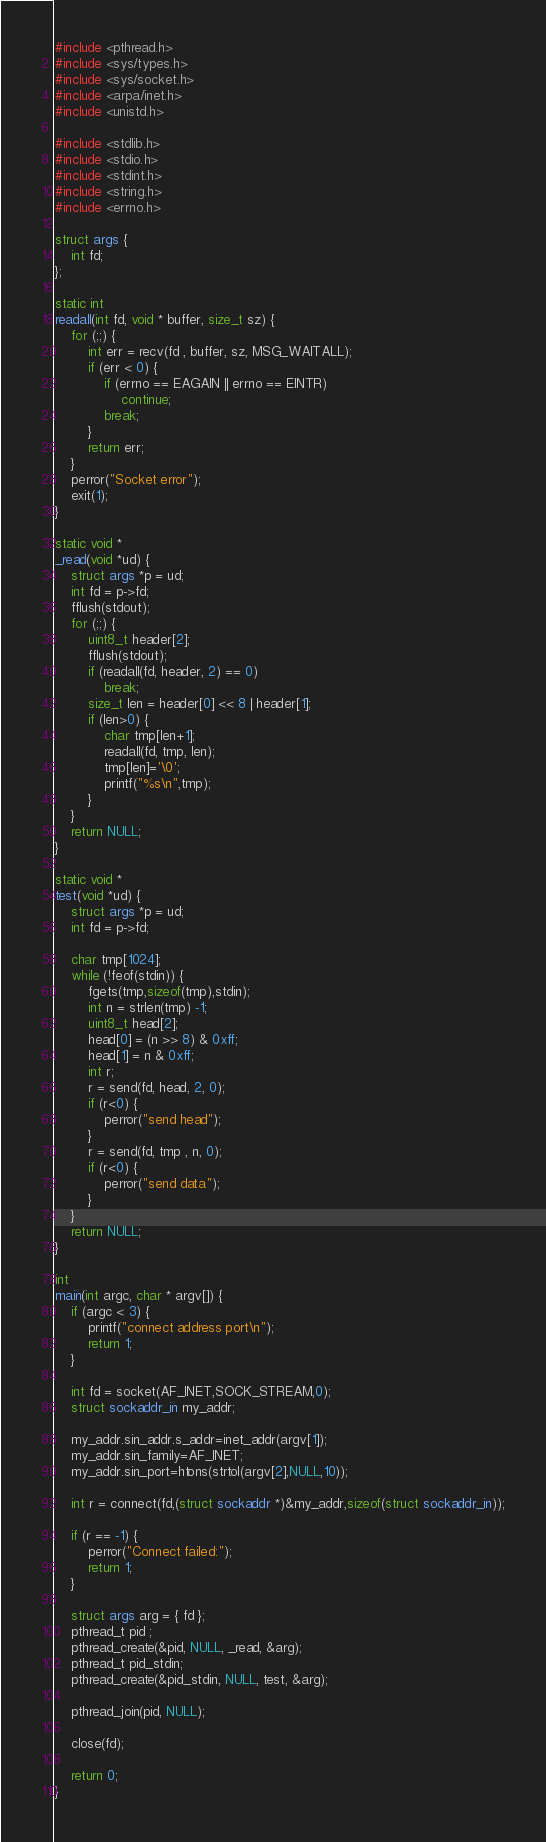<code> <loc_0><loc_0><loc_500><loc_500><_C_>#include <pthread.h>
#include <sys/types.h>
#include <sys/socket.h>
#include <arpa/inet.h>
#include <unistd.h>

#include <stdlib.h>
#include <stdio.h>
#include <stdint.h>
#include <string.h>
#include <errno.h>

struct args {
	int fd;
};

static int
readall(int fd, void * buffer, size_t sz) {
	for (;;) {
		int err = recv(fd , buffer, sz, MSG_WAITALL);
		if (err < 0) {
			if (errno == EAGAIN || errno == EINTR)
				continue;
			break;
		}
		return err;
	}
	perror("Socket error");
	exit(1);
}

static void *
_read(void *ud) {
	struct args *p = ud;
	int fd = p->fd;
	fflush(stdout);
	for (;;) {
		uint8_t header[2];
		fflush(stdout);
		if (readall(fd, header, 2) == 0)
			break;
		size_t len = header[0] << 8 | header[1];
		if (len>0) {
			char tmp[len+1];
			readall(fd, tmp, len);
			tmp[len]='\0';
			printf("%s\n",tmp);
		}
	}
	return NULL;
}

static void *
test(void *ud) {
	struct args *p = ud;
	int fd = p->fd;

	char tmp[1024];
	while (!feof(stdin)) {
		fgets(tmp,sizeof(tmp),stdin);
		int n = strlen(tmp) -1;
		uint8_t head[2];
		head[0] = (n >> 8) & 0xff;
		head[1] = n & 0xff;
		int r;
		r = send(fd, head, 2, 0);
		if (r<0) {
			perror("send head");
		}
		r = send(fd, tmp , n, 0);
		if (r<0) {
			perror("send data");
		}
	}
	return NULL;
}

int 
main(int argc, char * argv[]) {
	if (argc < 3) {
		printf("connect address port\n");
		return 1;
	}

	int fd = socket(AF_INET,SOCK_STREAM,0);
	struct sockaddr_in my_addr;

	my_addr.sin_addr.s_addr=inet_addr(argv[1]);
	my_addr.sin_family=AF_INET;
	my_addr.sin_port=htons(strtol(argv[2],NULL,10));

	int r = connect(fd,(struct sockaddr *)&my_addr,sizeof(struct sockaddr_in));

	if (r == -1) {
		perror("Connect failed:");
		return 1;
	}

	struct args arg = { fd };
	pthread_t pid ;
	pthread_create(&pid, NULL, _read, &arg);
	pthread_t pid_stdin;
	pthread_create(&pid_stdin, NULL, test, &arg);

	pthread_join(pid, NULL); 

	close(fd);

	return 0;
}</code> 